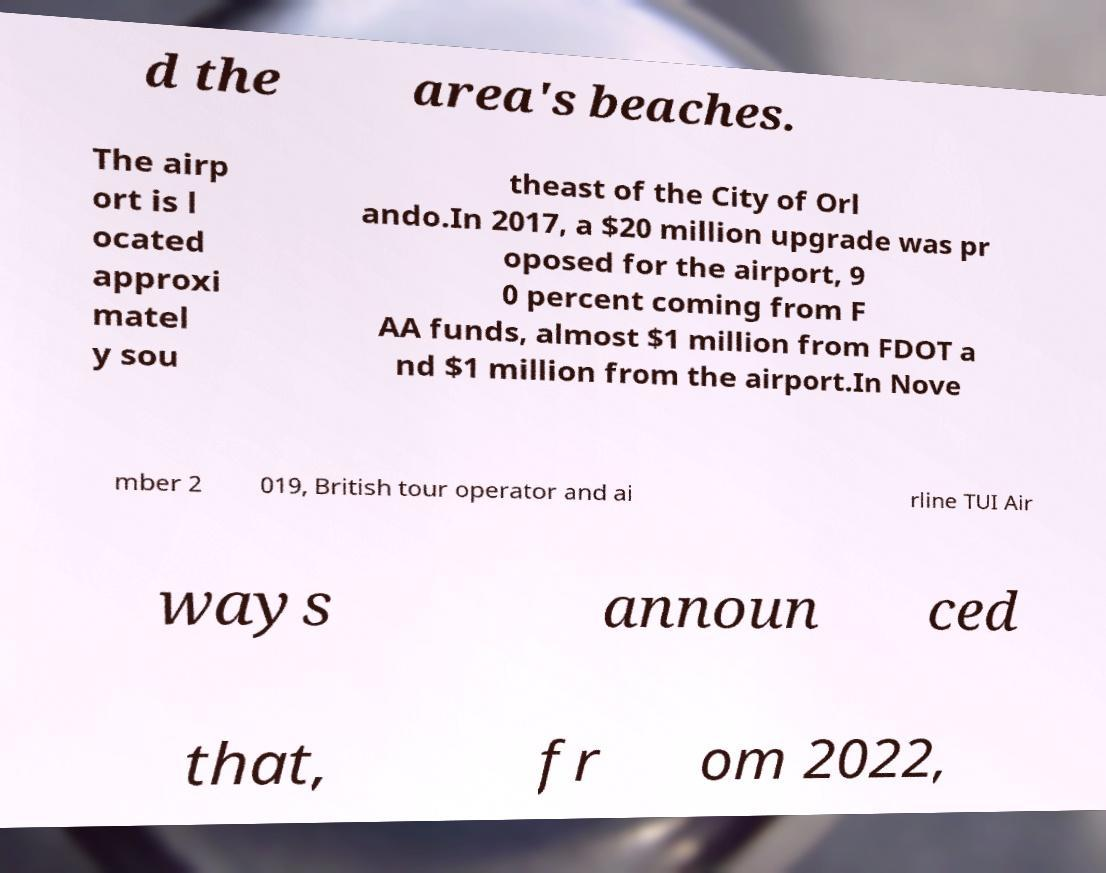What messages or text are displayed in this image? I need them in a readable, typed format. d the area's beaches. The airp ort is l ocated approxi matel y sou theast of the City of Orl ando.In 2017, a $20 million upgrade was pr oposed for the airport, 9 0 percent coming from F AA funds, almost $1 million from FDOT a nd $1 million from the airport.In Nove mber 2 019, British tour operator and ai rline TUI Air ways announ ced that, fr om 2022, 